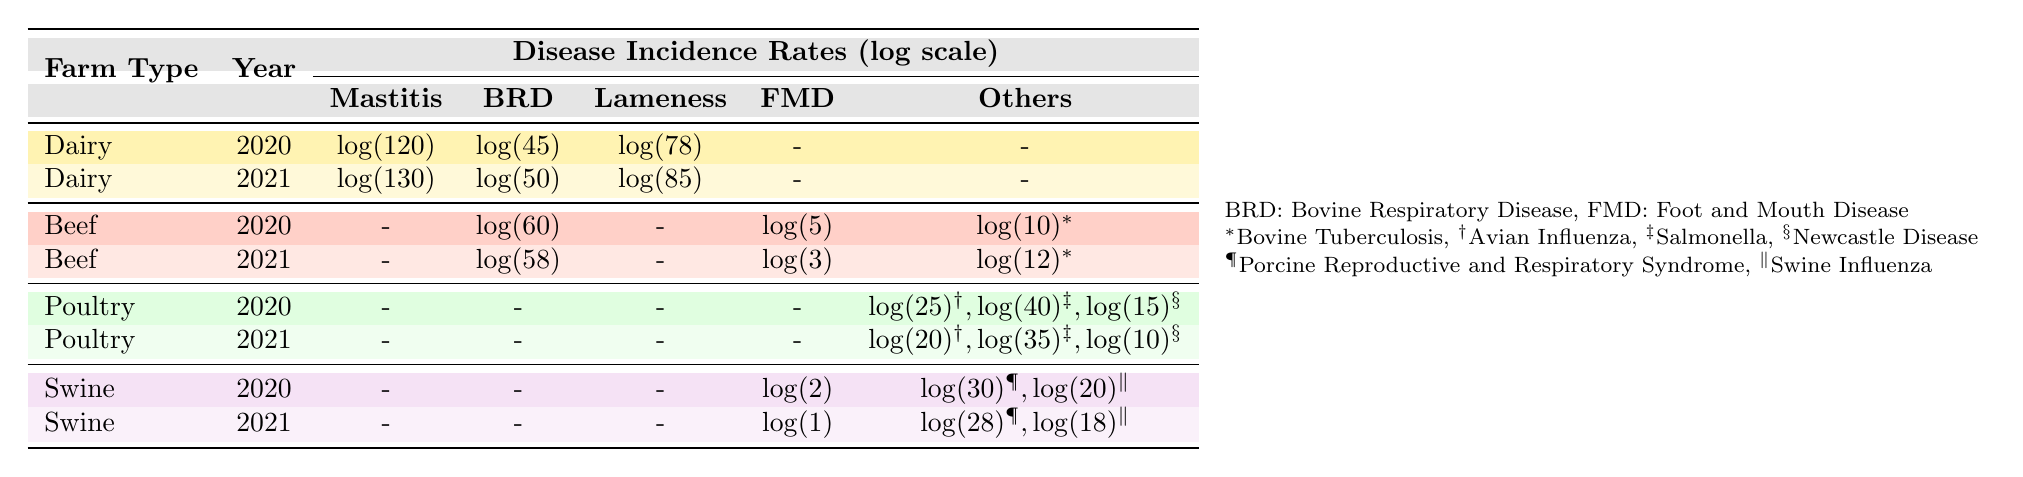What is the incidence rate of Mastitis in Dairy farms in 2021? The table shows the incidence rates for Dairy farms in 2021. Looking at the specific row for Dairy farms in 2021, the value given for Mastitis is log(130).
Answer: log(130) What's the incidence rate of Bovine Tuberculosis in Beef farms for both years provided? From the table, Bovine Tuberculosis is listed under Beef farms for the years 2020 and 2021. The incidence rates are log(10) for 2020 and log(12) for 2021.
Answer: log(10), log(12) Is the incidence of Salmonella in Poultry farms higher in 2020 compared to 2021? Looking at the table, the incidence rate for Salmonella in Poultry farms is log(40) in 2020 and log(35) in 2021. Since log(40) > log(35), it is higher in 2020.
Answer: Yes What is the difference in incidence rates of Bovine Respiratory Disease between Dairy and Beef farms in 2021? For Dairy farms in 2021, the incidence rate of Bovine Respiratory Disease is log(50), and for Beef farms in 2021, it is log(58). To find the difference, we subtract log(50) from log(58) which is equivalent to log(58) - log(50) = log(58/50).
Answer: log(58) - log(50) Which farm type had the highest incidence rate of Lameness in 2020? Referring to the table, only Dairy farm has an incidence rate for Lameness in 2020 which is log(78). In 2020, no other farm type shows an incidence for Lameness. Thus, Dairy farms had the highest incidence rate of Lameness.
Answer: Dairy 